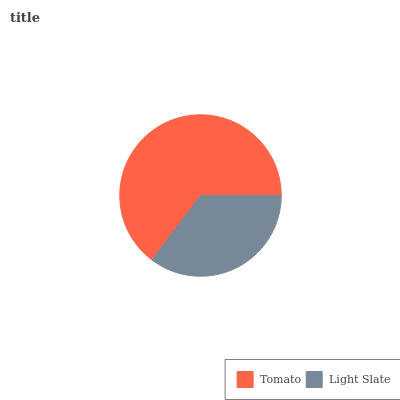Is Light Slate the minimum?
Answer yes or no. Yes. Is Tomato the maximum?
Answer yes or no. Yes. Is Light Slate the maximum?
Answer yes or no. No. Is Tomato greater than Light Slate?
Answer yes or no. Yes. Is Light Slate less than Tomato?
Answer yes or no. Yes. Is Light Slate greater than Tomato?
Answer yes or no. No. Is Tomato less than Light Slate?
Answer yes or no. No. Is Tomato the high median?
Answer yes or no. Yes. Is Light Slate the low median?
Answer yes or no. Yes. Is Light Slate the high median?
Answer yes or no. No. Is Tomato the low median?
Answer yes or no. No. 